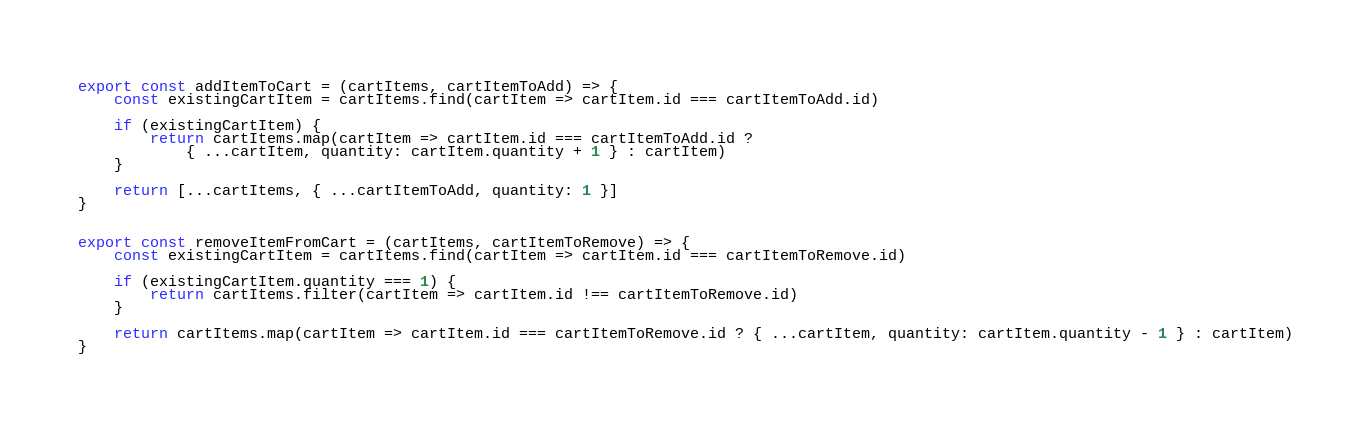Convert code to text. <code><loc_0><loc_0><loc_500><loc_500><_JavaScript_>export const addItemToCart = (cartItems, cartItemToAdd) => {
    const existingCartItem = cartItems.find(cartItem => cartItem.id === cartItemToAdd.id)

    if (existingCartItem) {
        return cartItems.map(cartItem => cartItem.id === cartItemToAdd.id ?
            { ...cartItem, quantity: cartItem.quantity + 1 } : cartItem)
    }

    return [...cartItems, { ...cartItemToAdd, quantity: 1 }]
}


export const removeItemFromCart = (cartItems, cartItemToRemove) => {
    const existingCartItem = cartItems.find(cartItem => cartItem.id === cartItemToRemove.id)

    if (existingCartItem.quantity === 1) {
        return cartItems.filter(cartItem => cartItem.id !== cartItemToRemove.id)
    }

    return cartItems.map(cartItem => cartItem.id === cartItemToRemove.id ? { ...cartItem, quantity: cartItem.quantity - 1 } : cartItem)
}</code> 